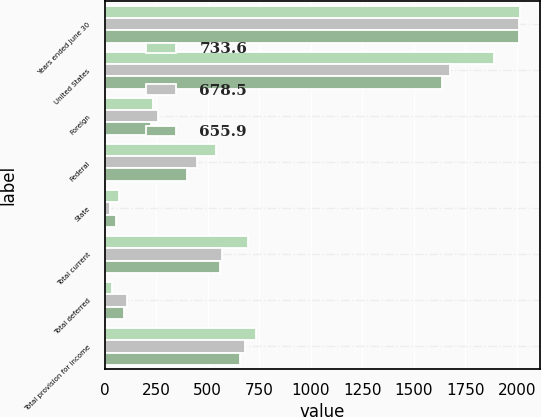<chart> <loc_0><loc_0><loc_500><loc_500><stacked_bar_chart><ecel><fcel>Years ended June 30<fcel>United States<fcel>Foreign<fcel>Federal<fcel>State<fcel>Total current<fcel>Total deferred<fcel>Total provision for income<nl><fcel>733.6<fcel>2012<fcel>1888.6<fcel>233.5<fcel>540.4<fcel>67.8<fcel>695.5<fcel>38.1<fcel>733.6<nl><fcel>678.5<fcel>2011<fcel>1675.1<fcel>257.6<fcel>449.3<fcel>24.7<fcel>570.9<fcel>107.6<fcel>678.5<nl><fcel>655.9<fcel>2010<fcel>1638<fcel>225.2<fcel>401.3<fcel>54.1<fcel>559.8<fcel>96.1<fcel>655.9<nl></chart> 